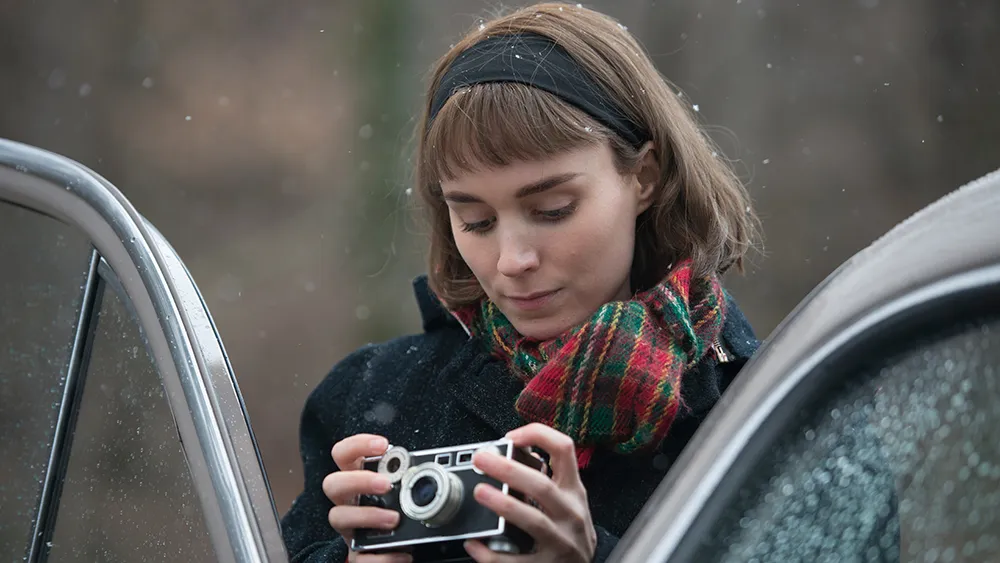What might she be thinking about in this moment? She could be lost in thought, contemplating the last few shots she captured with her camera. Perhaps she's reminiscing about the memories associated with each moment she froze in time, or she might be envisioning the perfect shot she aims to get next. The blend of serene surroundings and her focused expression suggests she is deeply immersed in the world of photography. Can you describe her surroundings in more detail? Absolutely. The scene appears to be set in a woodland area, given the blurred mix of greens and browns in the background, which could be foliage and tree trunks softened by the falling snow. The gentle snowfall adds a layer of calm and quiet to the scene, muffling any sounds that might typically populate such an area. The car alongside her, adorned with rain droplets, suggests it has been recently driven through the forest, now taking a moment's pause in this picturesque setting. 